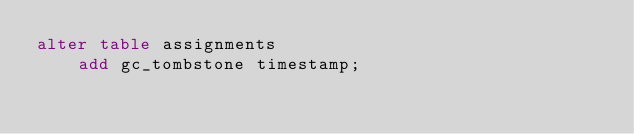Convert code to text. <code><loc_0><loc_0><loc_500><loc_500><_SQL_>alter table assignments
    add gc_tombstone timestamp;

</code> 